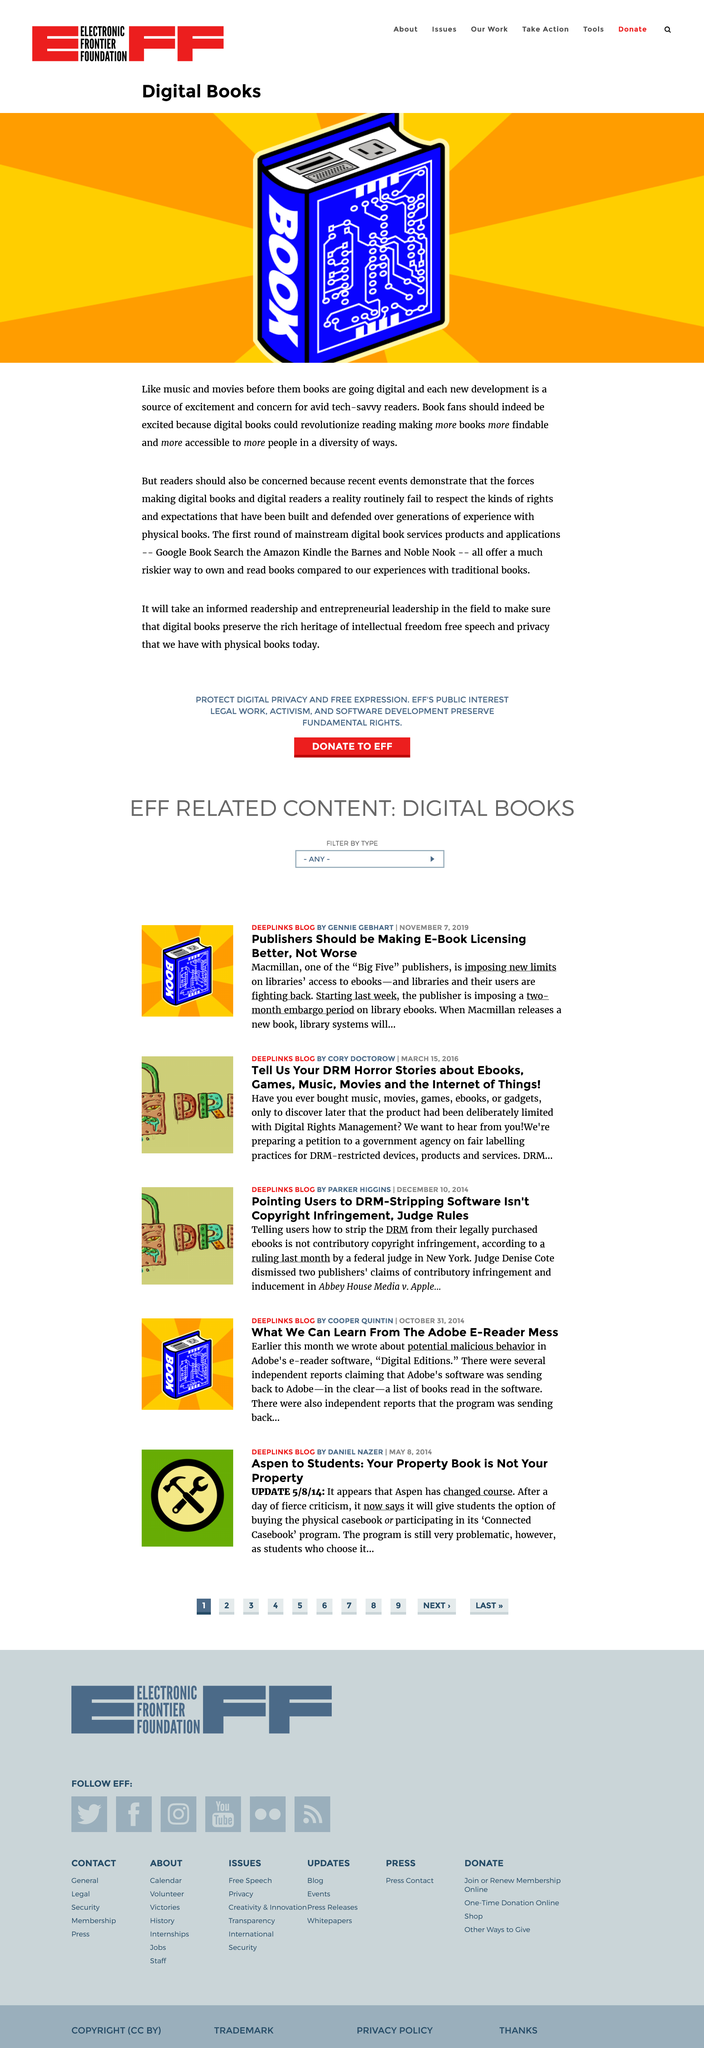Give some essential details in this illustration. It is imperative that readers also pay attention to this matter, as it has significant implications for them. Yes, Google Book Search is considered an example of mainstream digital book services. Yes, there is a rich heritage of intellectual freedom, free speech, and privacy with physical books. 